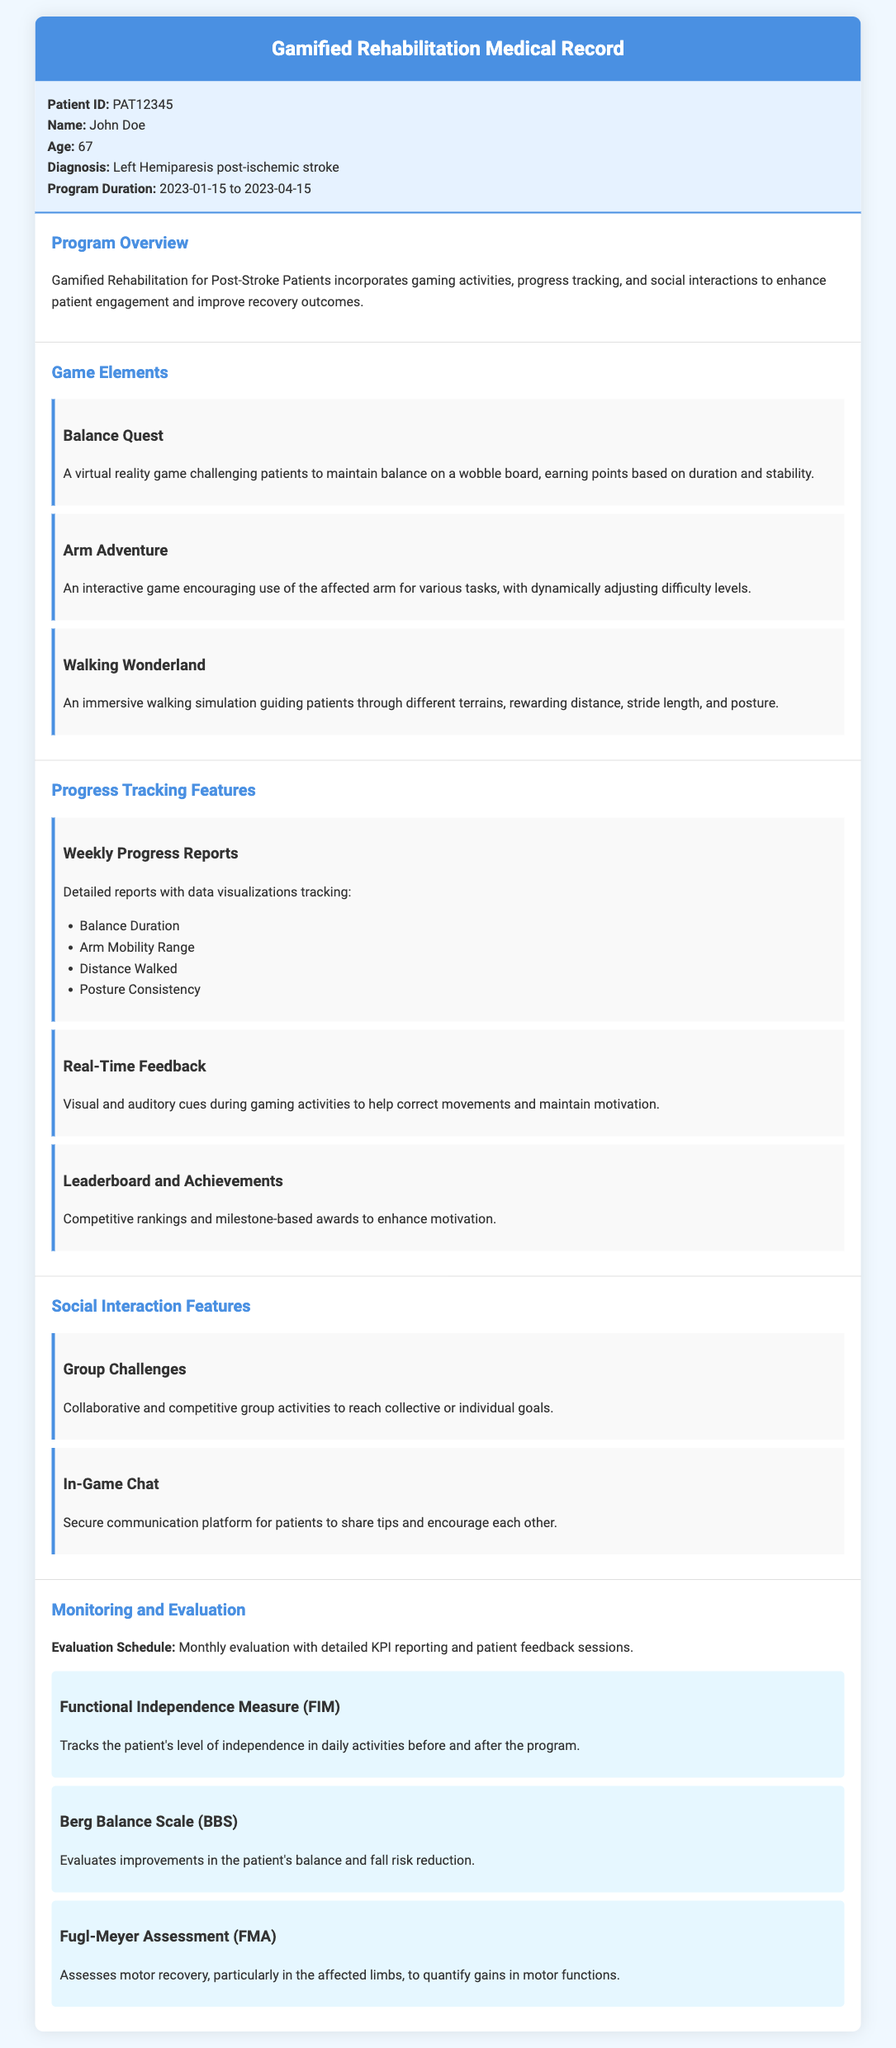What is the patient's name? The document states the patient's name is John Doe.
Answer: John Doe What is the age of the patient? The document specifies that the patient is 67 years old.
Answer: 67 What is the diagnosis of the patient? According to the document, the patient's diagnosis is Left Hemiparesis post-ischemic stroke.
Answer: Left Hemiparesis post-ischemic stroke What is the duration of the program? The program duration indicated in the document is from January 15, 2023, to April 15, 2023.
Answer: 2023-01-15 to 2023-04-15 What game element focuses on balance? The document mentions the game element "Balance Quest," which focuses on maintaining balance.
Answer: Balance Quest What type of reports are provided weekly? The document outlines that "Weekly Progress Reports" are provided to track patient progress.
Answer: Weekly Progress Reports How often are evaluations scheduled? The document specifies that evaluations are scheduled monthly.
Answer: Monthly What is the Functional Independence Measure? The document describes the Functional Independence Measure as tracking the patient's level of independence in daily activities.
Answer: Tracks the patient's level of independence in daily activities What features enhance patient motivation? The document includes "Leaderboard and Achievements" as features that enhance patient motivation.
Answer: Leaderboard and Achievements 